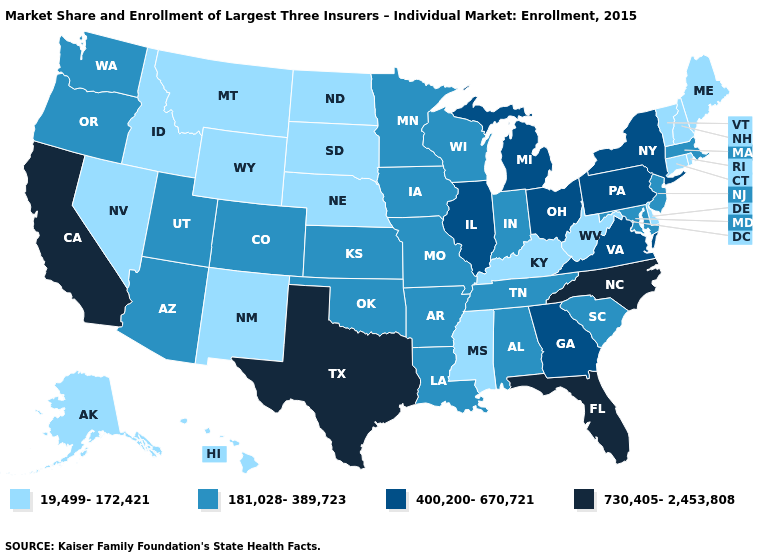Does Alabama have the same value as Arizona?
Quick response, please. Yes. What is the value of Kansas?
Short answer required. 181,028-389,723. Name the states that have a value in the range 400,200-670,721?
Give a very brief answer. Georgia, Illinois, Michigan, New York, Ohio, Pennsylvania, Virginia. Name the states that have a value in the range 400,200-670,721?
Give a very brief answer. Georgia, Illinois, Michigan, New York, Ohio, Pennsylvania, Virginia. Name the states that have a value in the range 19,499-172,421?
Give a very brief answer. Alaska, Connecticut, Delaware, Hawaii, Idaho, Kentucky, Maine, Mississippi, Montana, Nebraska, Nevada, New Hampshire, New Mexico, North Dakota, Rhode Island, South Dakota, Vermont, West Virginia, Wyoming. Among the states that border South Dakota , does Montana have the lowest value?
Be succinct. Yes. Does the map have missing data?
Answer briefly. No. What is the highest value in the USA?
Be succinct. 730,405-2,453,808. Name the states that have a value in the range 400,200-670,721?
Answer briefly. Georgia, Illinois, Michigan, New York, Ohio, Pennsylvania, Virginia. Name the states that have a value in the range 400,200-670,721?
Answer briefly. Georgia, Illinois, Michigan, New York, Ohio, Pennsylvania, Virginia. Name the states that have a value in the range 400,200-670,721?
Write a very short answer. Georgia, Illinois, Michigan, New York, Ohio, Pennsylvania, Virginia. Does Pennsylvania have the lowest value in the USA?
Write a very short answer. No. Does Iowa have the same value as South Dakota?
Be succinct. No. What is the value of New Hampshire?
Give a very brief answer. 19,499-172,421. Which states have the lowest value in the USA?
Give a very brief answer. Alaska, Connecticut, Delaware, Hawaii, Idaho, Kentucky, Maine, Mississippi, Montana, Nebraska, Nevada, New Hampshire, New Mexico, North Dakota, Rhode Island, South Dakota, Vermont, West Virginia, Wyoming. 